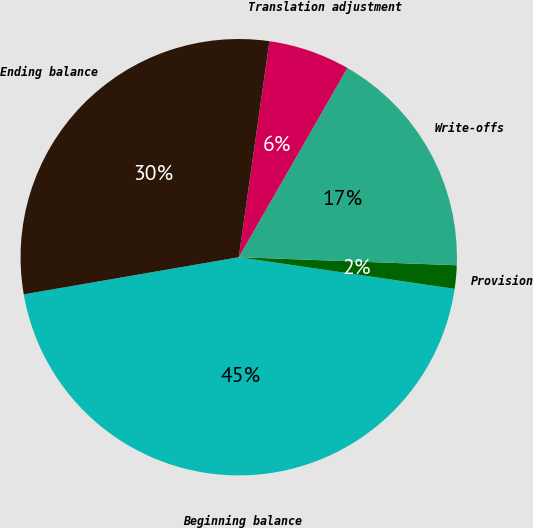Convert chart. <chart><loc_0><loc_0><loc_500><loc_500><pie_chart><fcel>Beginning balance<fcel>Provision<fcel>Write-offs<fcel>Translation adjustment<fcel>Ending balance<nl><fcel>44.96%<fcel>1.73%<fcel>17.29%<fcel>6.05%<fcel>29.97%<nl></chart> 